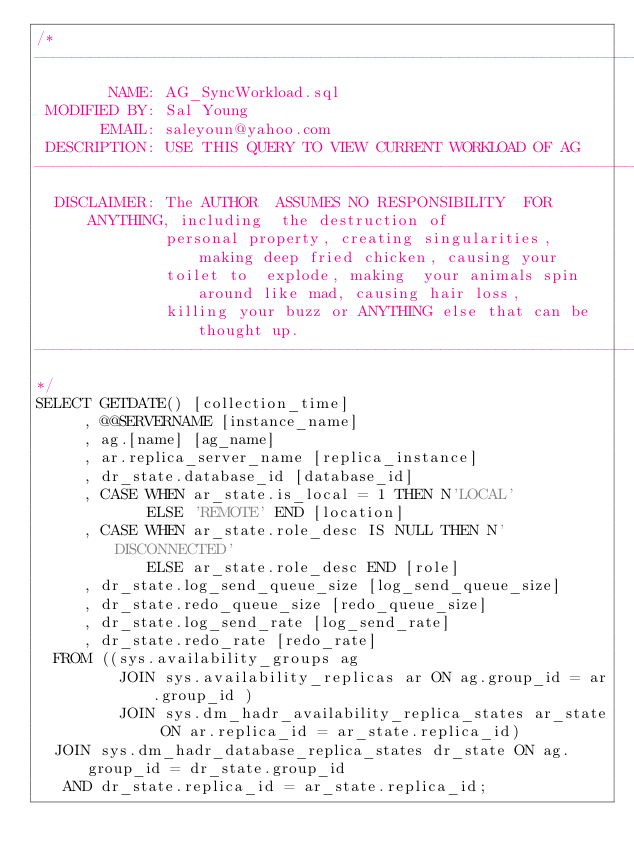Convert code to text. <code><loc_0><loc_0><loc_500><loc_500><_SQL_>/*
-------------------------------------------------------------------------------------------------
        NAME: AG_SyncWorkload.sql
 MODIFIED BY: Sal Young
       EMAIL: saleyoun@yahoo.com
 DESCRIPTION: USE THIS QUERY TO VIEW CURRENT WORKLOAD OF AG
-------------------------------------------------------------------------------------------------
  DISCLAIMER: The AUTHOR  ASSUMES NO RESPONSIBILITY  FOR ANYTHING, including  the destruction of 
              personal property, creating singularities, making deep fried chicken, causing your 
              toilet to  explode, making  your animals spin  around like mad, causing hair loss, 
              killing your buzz or ANYTHING else that can be thought up.
-------------------------------------------------------------------------------------------------
*/
SELECT GETDATE() [collection_time]
     , @@SERVERNAME [instance_name]
     , ag.[name] [ag_name]
     , ar.replica_server_name [replica_instance]
     , dr_state.database_id [database_id]
     , CASE WHEN ar_state.is_local = 1 THEN N'LOCAL'
            ELSE 'REMOTE' END [location] 
     , CASE WHEN ar_state.role_desc IS NULL THEN N'DISCONNECTED'
            ELSE ar_state.role_desc END [role]
     , dr_state.log_send_queue_size [log_send_queue_size]
     , dr_state.redo_queue_size [redo_queue_size]
     , dr_state.log_send_rate [log_send_rate]
     , dr_state.redo_rate [redo_rate]
  FROM ((sys.availability_groups ag 
         JOIN sys.availability_replicas ar ON ag.group_id = ar.group_id )
         JOIN sys.dm_hadr_availability_replica_states ar_state ON ar.replica_id = ar_state.replica_id)
  JOIN sys.dm_hadr_database_replica_states dr_state ON ag.group_id = dr_state.group_id 
   AND dr_state.replica_id = ar_state.replica_id;
   </code> 